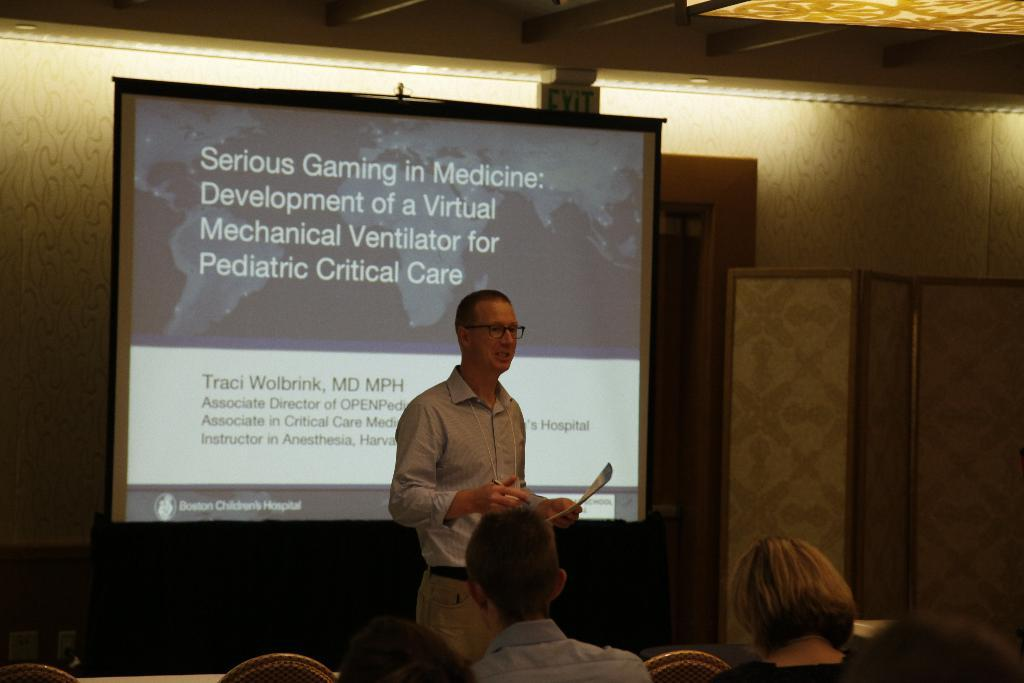Who is present in the image? There is a man in the image. What is the man doing in the image? The man is standing in front of a screen and holding a book. What can be seen on the ceiling in the image? There are lights on the ceiling. What is happening in the background of the image? There are people sitting on chairs in the background. How does the man's friend help him cough in the image? There is no friend present in the image, nor is there any indication that the man is coughing. 